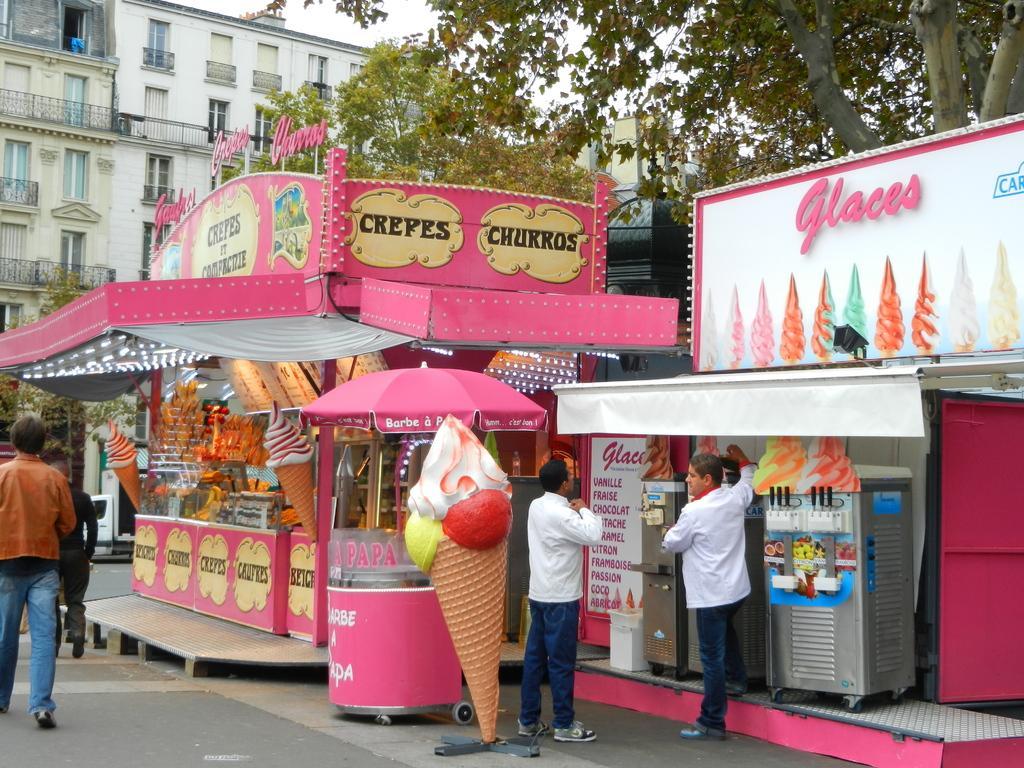Can you describe this image briefly? In this image I can see two ice cream shops visible on the road. And I can see a pink color tent , under the tent I can see a ice-cream statue, in front of the that I can see persons walking on the road, and I can see buildings and the tree. 